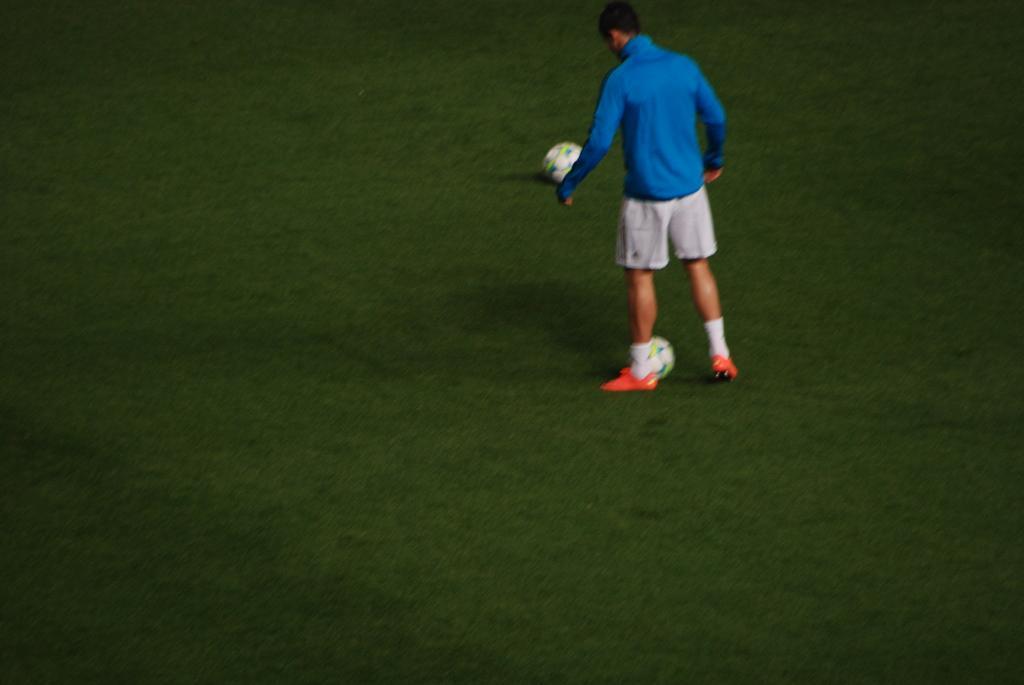Can you describe this image briefly? As we can see in the image there is grass, balls and a person wearing blue color shirt. 